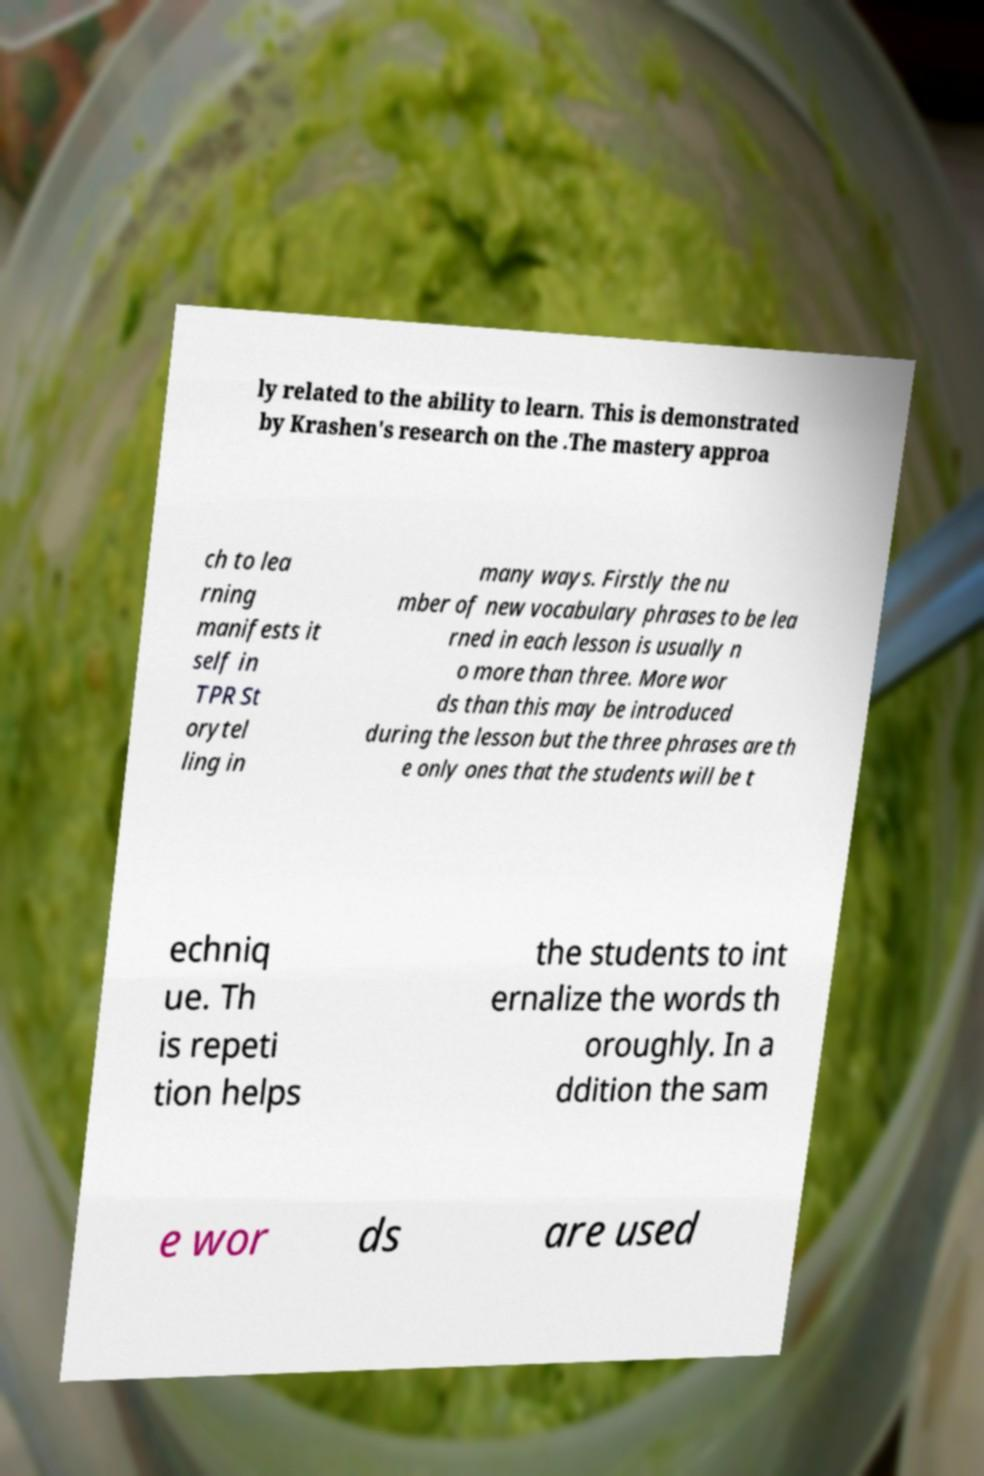There's text embedded in this image that I need extracted. Can you transcribe it verbatim? ly related to the ability to learn. This is demonstrated by Krashen's research on the .The mastery approa ch to lea rning manifests it self in TPR St orytel ling in many ways. Firstly the nu mber of new vocabulary phrases to be lea rned in each lesson is usually n o more than three. More wor ds than this may be introduced during the lesson but the three phrases are th e only ones that the students will be t echniq ue. Th is repeti tion helps the students to int ernalize the words th oroughly. In a ddition the sam e wor ds are used 